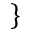<formula> <loc_0><loc_0><loc_500><loc_500>\}</formula> 